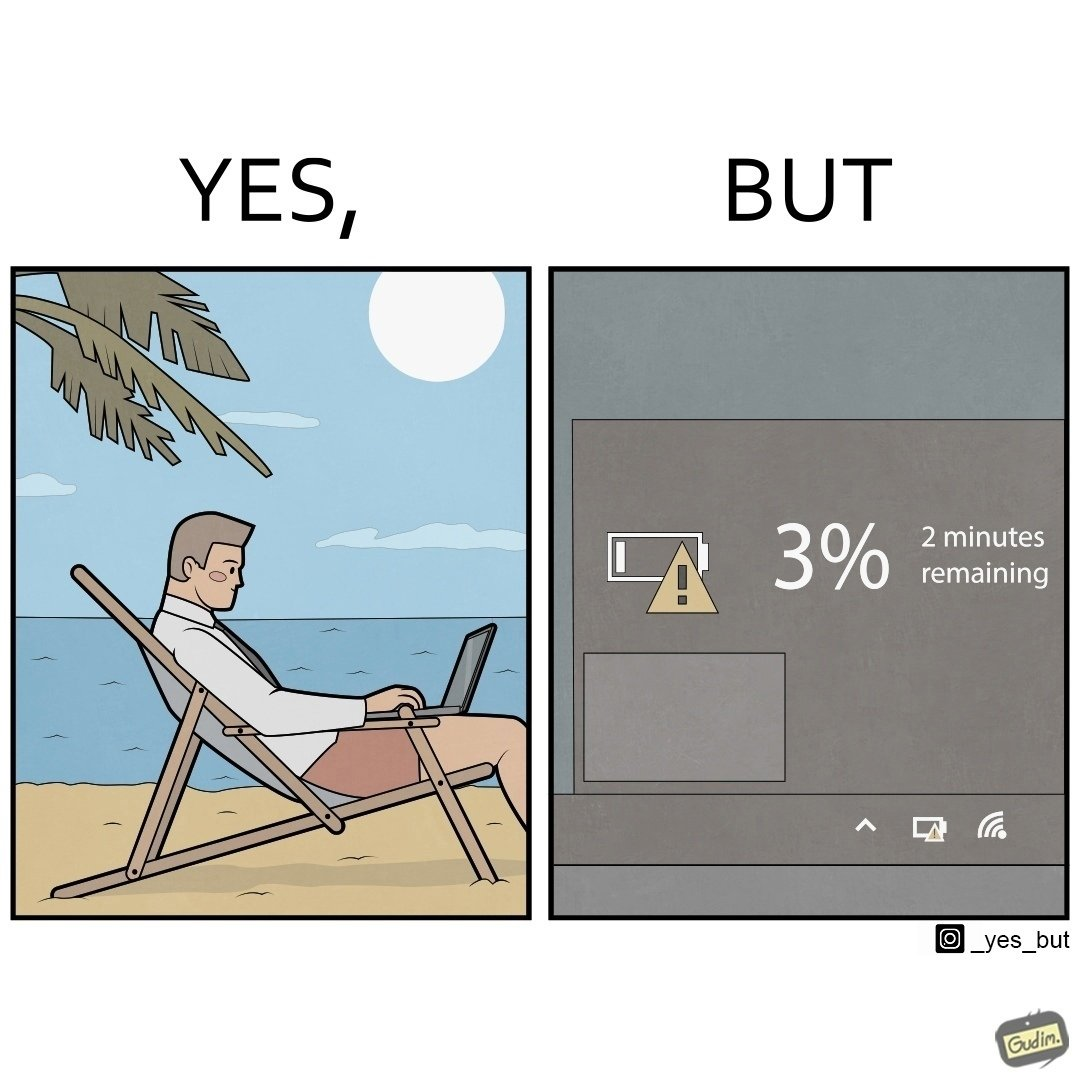Describe what you see in this image. The image is ironical, as a person is working on a laptop in a beach, which looks like a soothing and calm environment to work. However, the laptop is about to get discharged, and there is probably no electric supply to keep the laptop open while working on the beach, turning the situation into an inconvenience. 